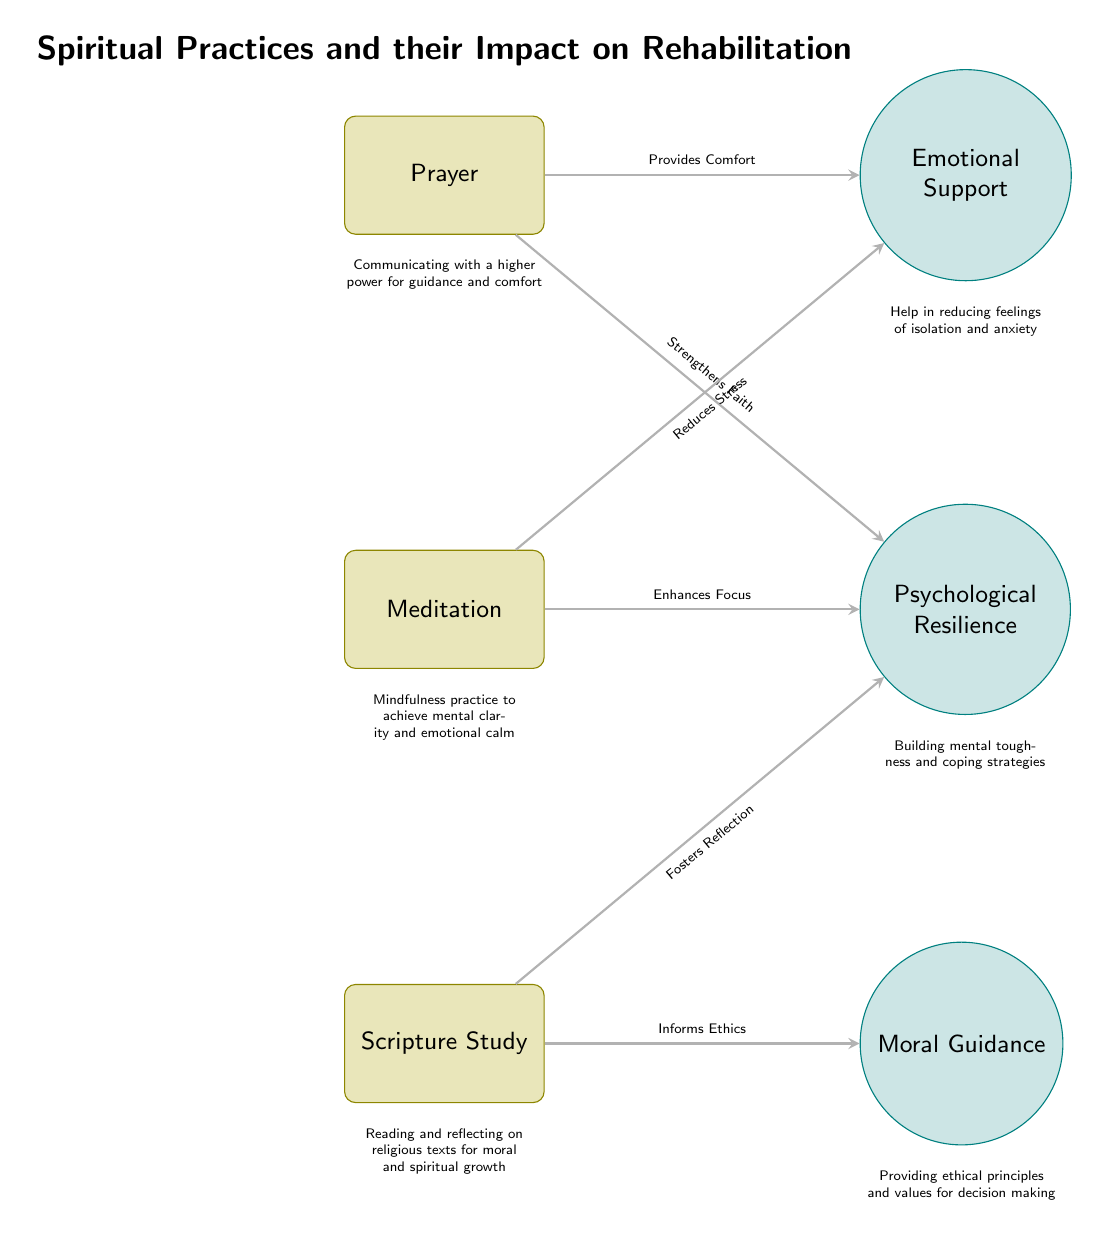What are the three spiritual practices illustrated in the diagram? The diagram lists three spiritual practices: Prayer, Meditation, and Scripture Study. These are the main nodes depicted in the diagram.
Answer: Prayer, Meditation, Scripture Study How many impacts are related to Meditation? The diagram shows two impacts stemming from Meditation: Psychological Resilience and Emotional Support. Thus, there are two impacts connected to this practice.
Answer: 2 What impact does Prayer provide related to emotional support? The arrow from Prayer to Emotional Support indicates that Prayer "Provides Comfort," which directly describes the emotional impact associated with this spiritual practice.
Answer: Provides Comfort What impact is connected to Scripture Study? Scripture Study is linked to Moral Guidance, indicated by the arrow pointing from Scripture Study to Moral Guidance in the diagram.
Answer: Moral Guidance Which spiritual practice reduces stress? The diagram shows that Meditation reduces stress, as indicated by the arrow from Meditation to Emotional Support stating "Reduces Stress."
Answer: Meditation What is the relationship between Meditation and Psychological Resilience? The arrow from Meditation to Psychological Resilience indicates that Meditation "Enhances Focus," which contributes positively to Psychological Resilience.
Answer: Enhances Focus What role does Scripture Study play in moral guidance? The diagram states that Scripture Study "Informs Ethics," showing its role in providing moral guidance through religious texts.
Answer: Informs Ethics Which spiritual practice strengthens faith? The arrow leading from Prayer to Psychological Resilience shows that Prayer additionally "Strengthens Faith." Thus, Prayer is the practice that strengthens faith in this context.
Answer: Prayer How many total spiritual practices are shown in the diagram? The diagram visually depicts three spiritual practices: Prayer, Meditation, and Scripture Study. Therefore, the total number is three.
Answer: 3 